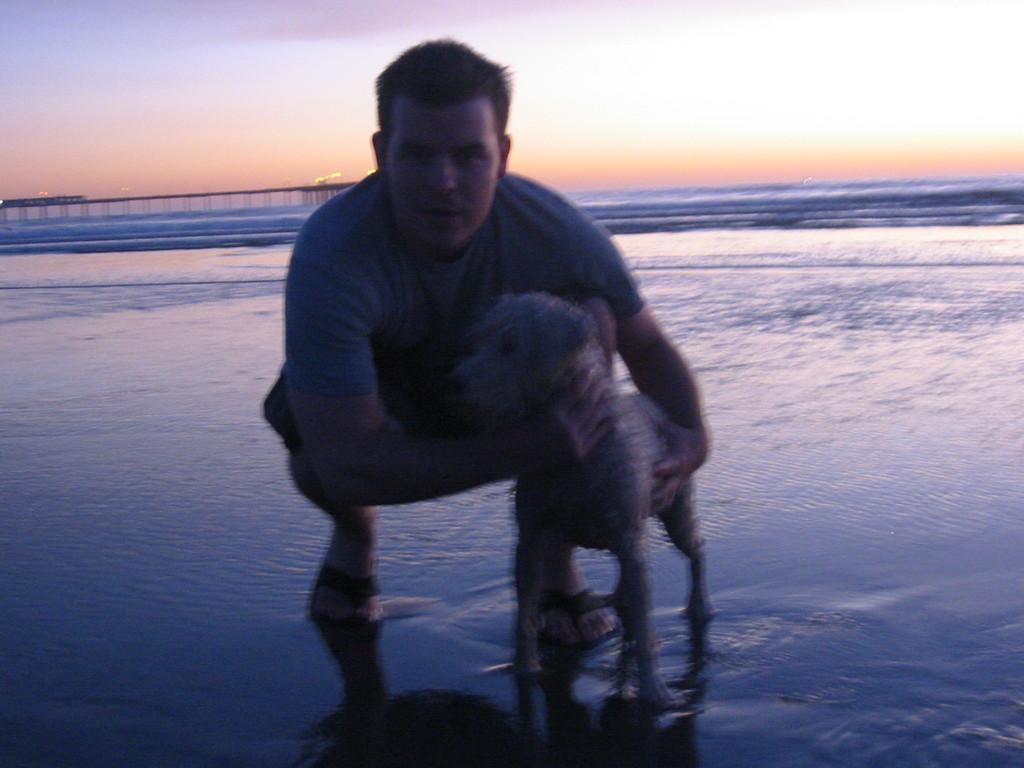Describe this image in one or two sentences. In this image there is a person bent down by holding a dog beside him is posing for the camera, behind the person there is a bridge on the water. 